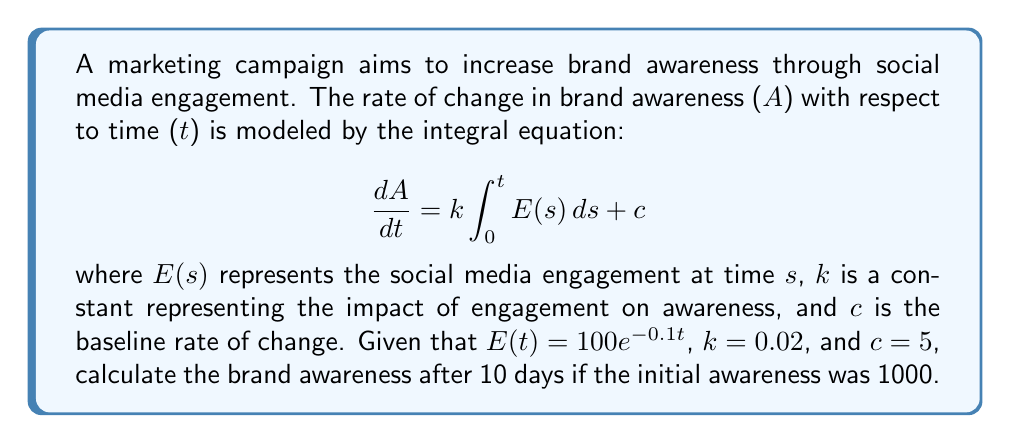Solve this math problem. To solve this problem, we'll follow these steps:

1) First, we need to solve the integral inside the equation:
   $$\int_0^t E(s) ds = \int_0^t 100e^{-0.1s} ds$$

2) Solving this integral:
   $$\int_0^t 100e^{-0.1s} ds = -1000e^{-0.1s} \Big|_0^t = -1000(e^{-0.1t} - 1)$$

3) Now our differential equation becomes:
   $$\frac{dA}{dt} = -20(e^{-0.1t} - 1) + 5$$

4) To find A(t), we integrate both sides:
   $$A(t) = \int (-20(e^{-0.1t} - 1) + 5) dt$$

5) Solving this integral:
   $$A(t) = 200e^{-0.1t} + 20t + 5t + C$$
   where C is a constant of integration.

6) To find C, we use the initial condition A(0) = 1000:
   $$1000 = 200 + C$$
   $$C = 800$$

7) Therefore, our final equation for A(t) is:
   $$A(t) = 200e^{-0.1t} + 25t + 800$$

8) To find the brand awareness after 10 days, we calculate A(10):
   $$A(10) = 200e^{-1} + 25(10) + 800$$
   $$A(10) = 73.58 + 250 + 800 = 1123.58$$
Answer: 1123.58 